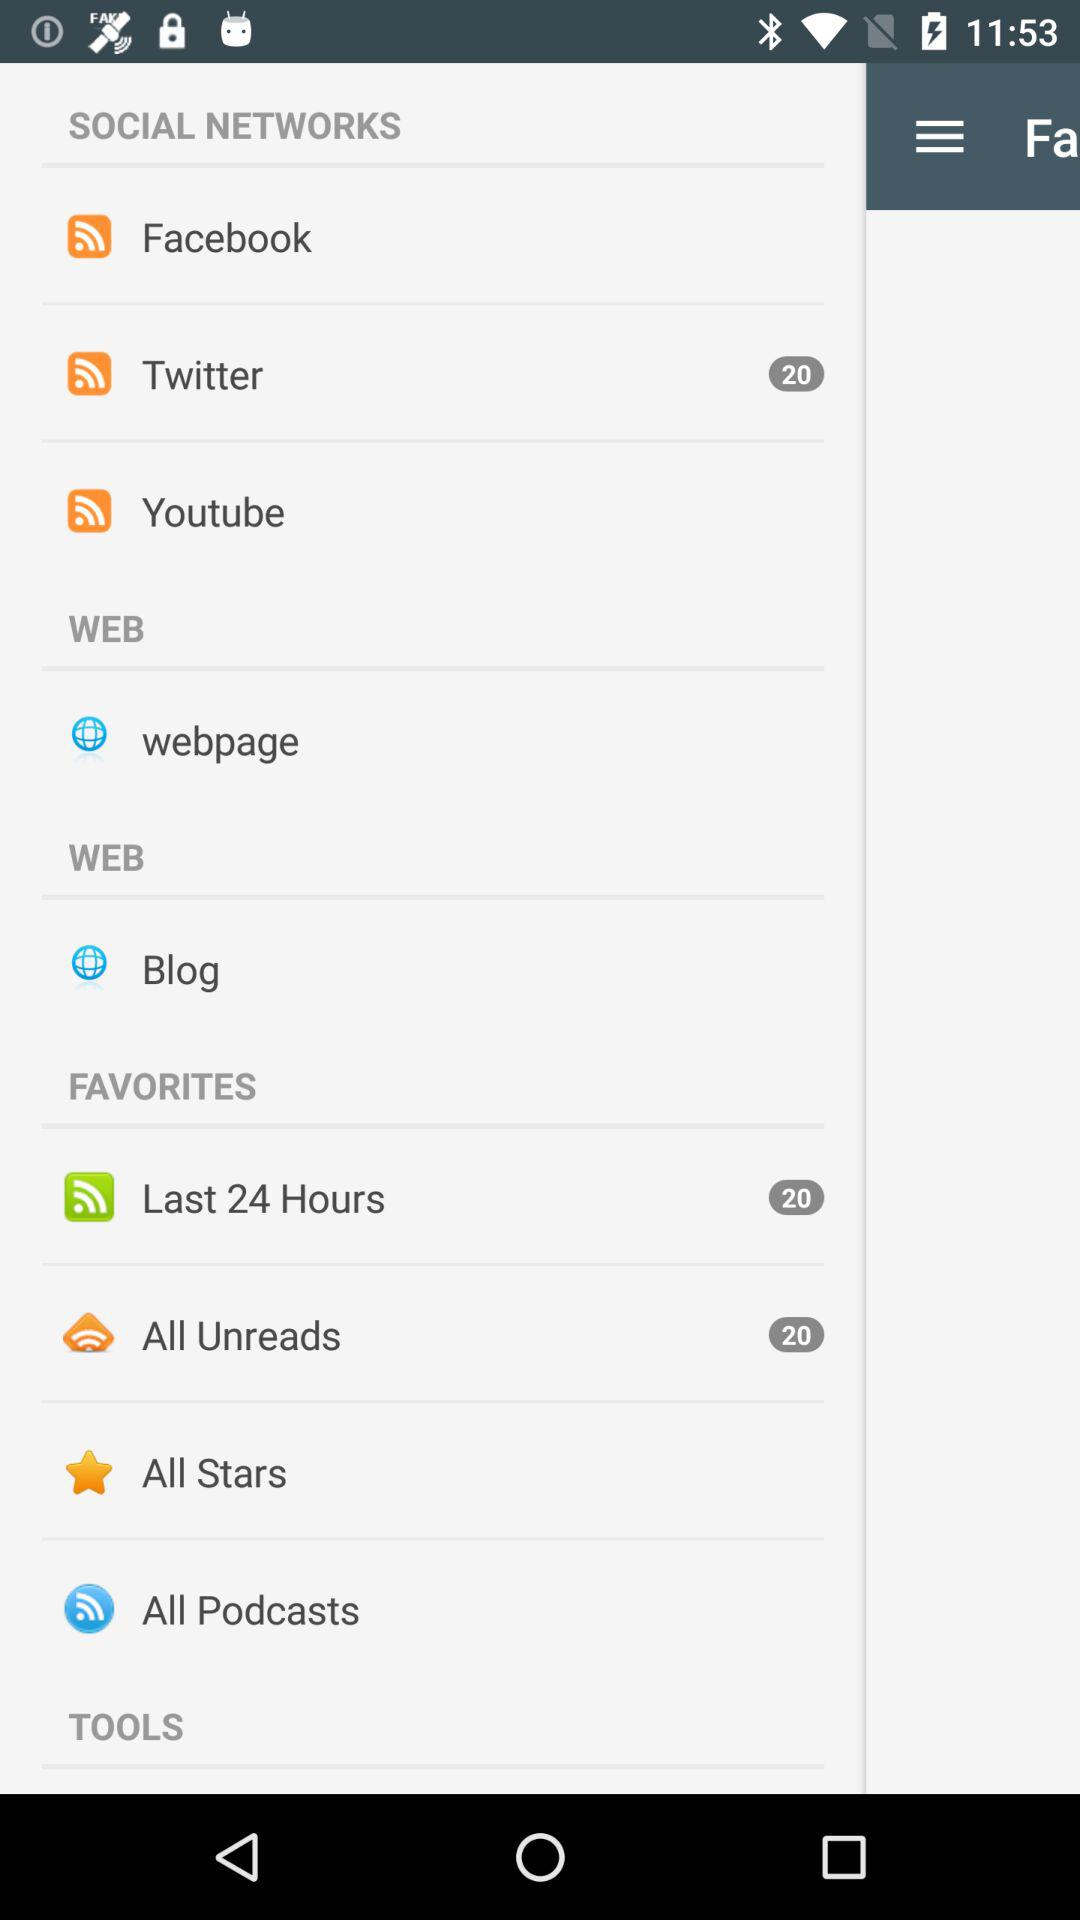What is the notification count for the last 24 hours? The notification count for the last 24 hours is 20. 